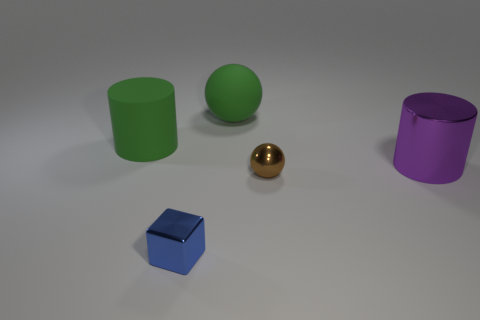Add 3 brown things. How many objects exist? 8 Subtract all spheres. How many objects are left? 3 Subtract all large green shiny spheres. Subtract all large purple cylinders. How many objects are left? 4 Add 2 purple objects. How many purple objects are left? 3 Add 2 matte balls. How many matte balls exist? 3 Subtract 0 red spheres. How many objects are left? 5 